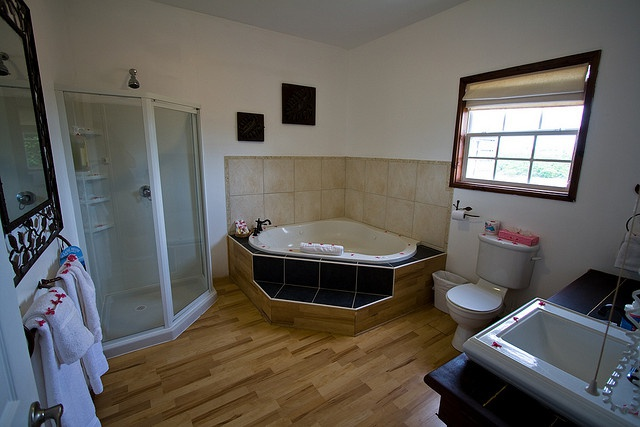Describe the objects in this image and their specific colors. I can see sink in black, gray, and blue tones and toilet in black, gray, darkgray, and maroon tones in this image. 